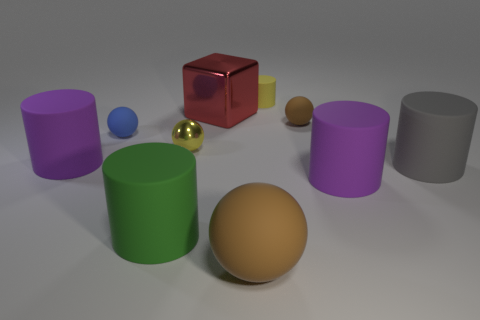How many cylinders are behind the green object and in front of the yellow cylinder?
Offer a terse response. 3. There is a blue object that is the same shape as the small yellow shiny object; what is its material?
Offer a very short reply. Rubber. What is the size of the brown ball that is in front of the large cylinder that is behind the gray rubber cylinder?
Your response must be concise. Large. Are there any blue metallic cubes?
Provide a short and direct response. No. What is the material of the small object that is both on the left side of the large shiny object and right of the green cylinder?
Your answer should be compact. Metal. Is the number of red objects in front of the green rubber cylinder greater than the number of large brown things that are behind the tiny yellow metallic sphere?
Your response must be concise. No. Is there a shiny cube that has the same size as the green cylinder?
Offer a very short reply. Yes. There is a purple thing that is right of the yellow sphere that is to the left of the purple cylinder in front of the gray cylinder; how big is it?
Provide a succinct answer. Large. The big metallic block is what color?
Keep it short and to the point. Red. Is the number of large purple objects that are left of the red metallic block greater than the number of cyan matte cubes?
Provide a short and direct response. Yes. 